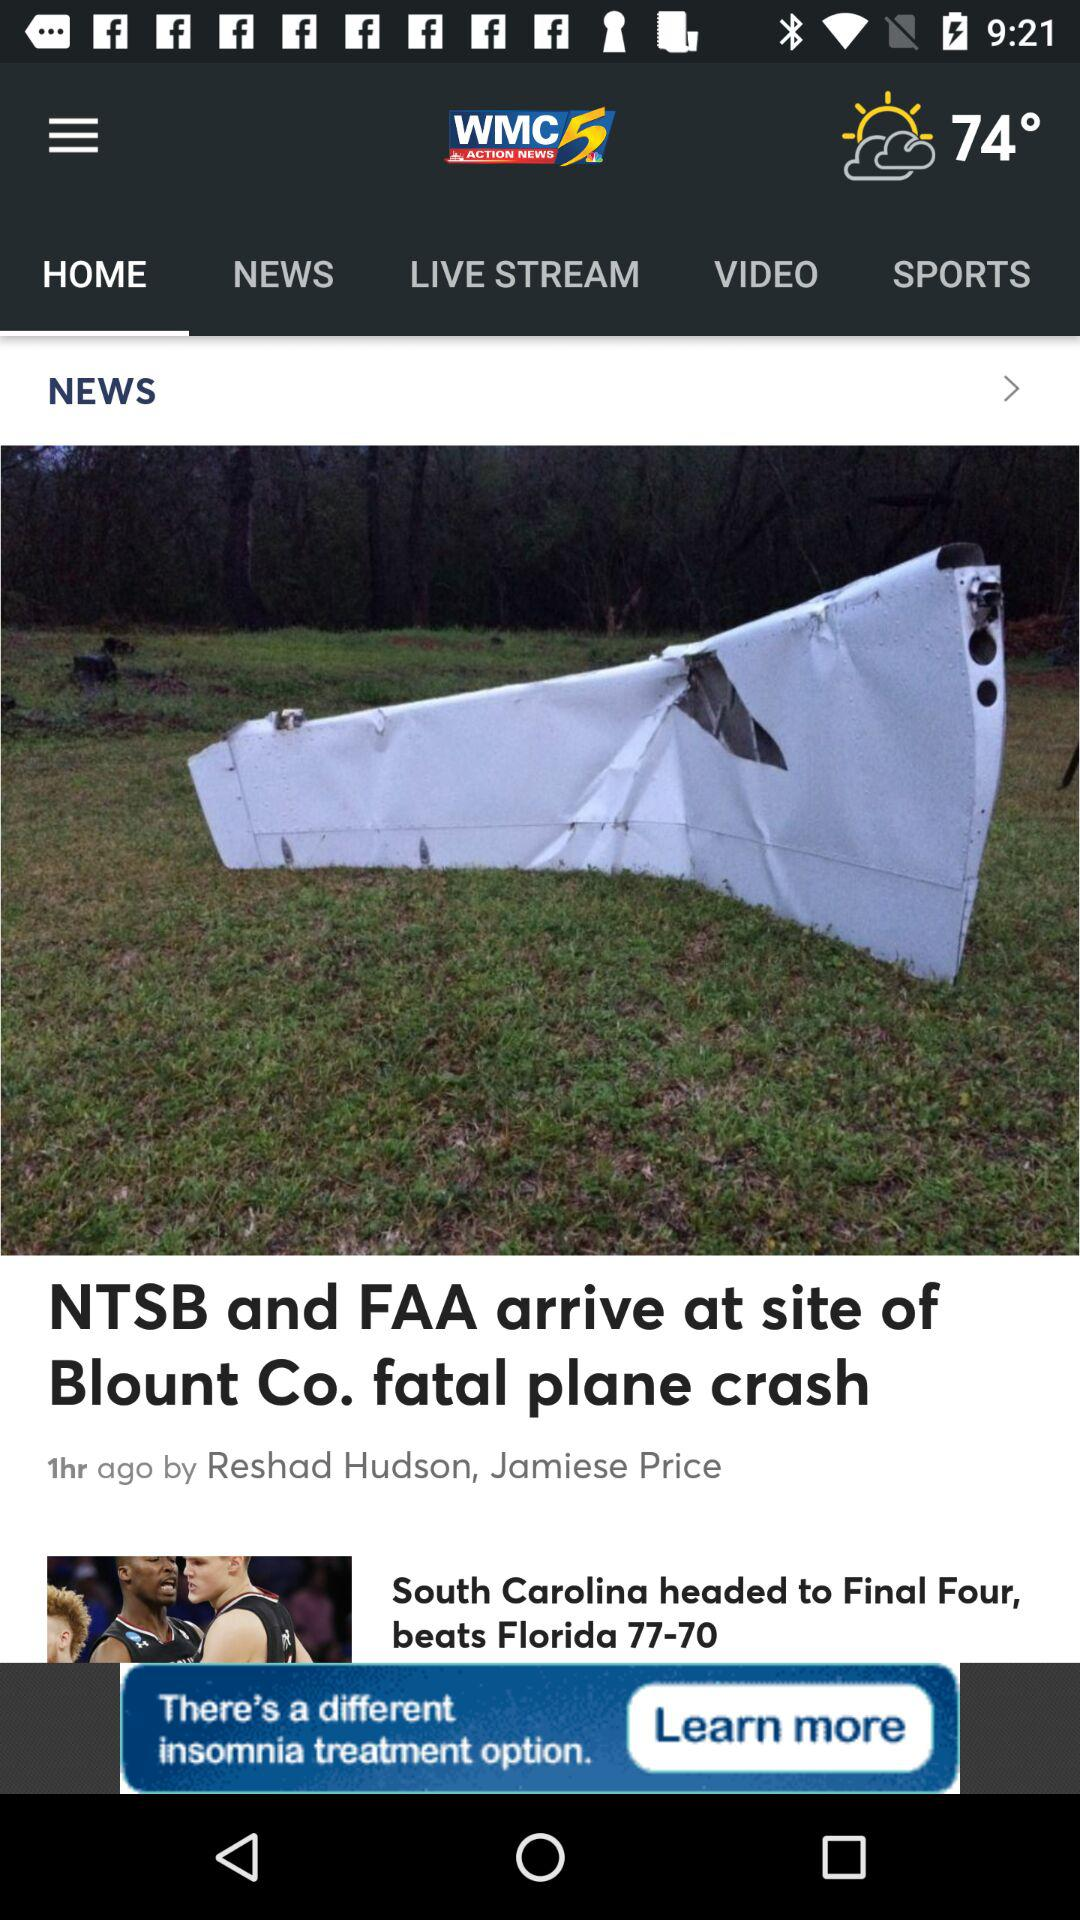What is the news channel name? The news channel name is "WMC ACTION NEWS 5". 